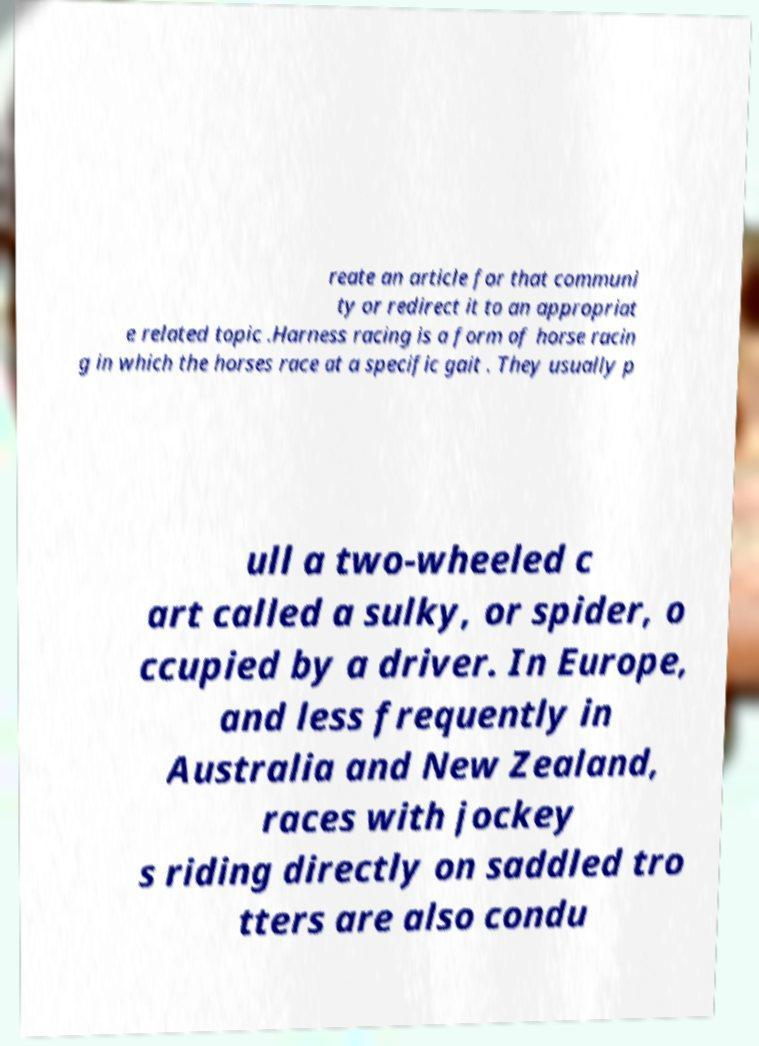What messages or text are displayed in this image? I need them in a readable, typed format. reate an article for that communi ty or redirect it to an appropriat e related topic .Harness racing is a form of horse racin g in which the horses race at a specific gait . They usually p ull a two-wheeled c art called a sulky, or spider, o ccupied by a driver. In Europe, and less frequently in Australia and New Zealand, races with jockey s riding directly on saddled tro tters are also condu 